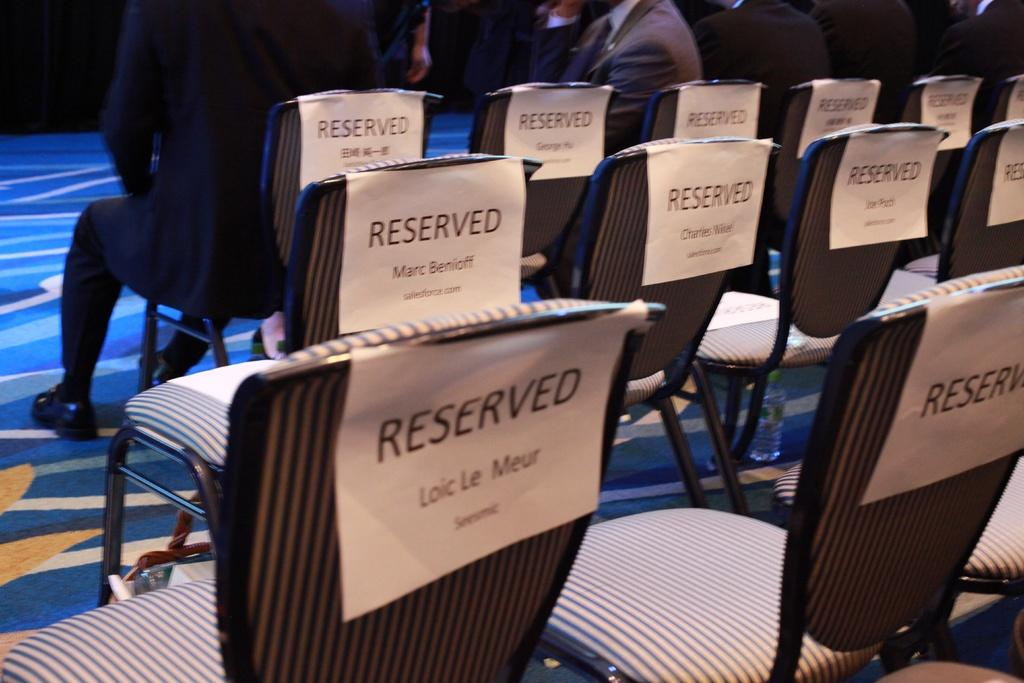<image>
Relay a brief, clear account of the picture shown. Seats have paper signs labelled RESERVED on their backs. 